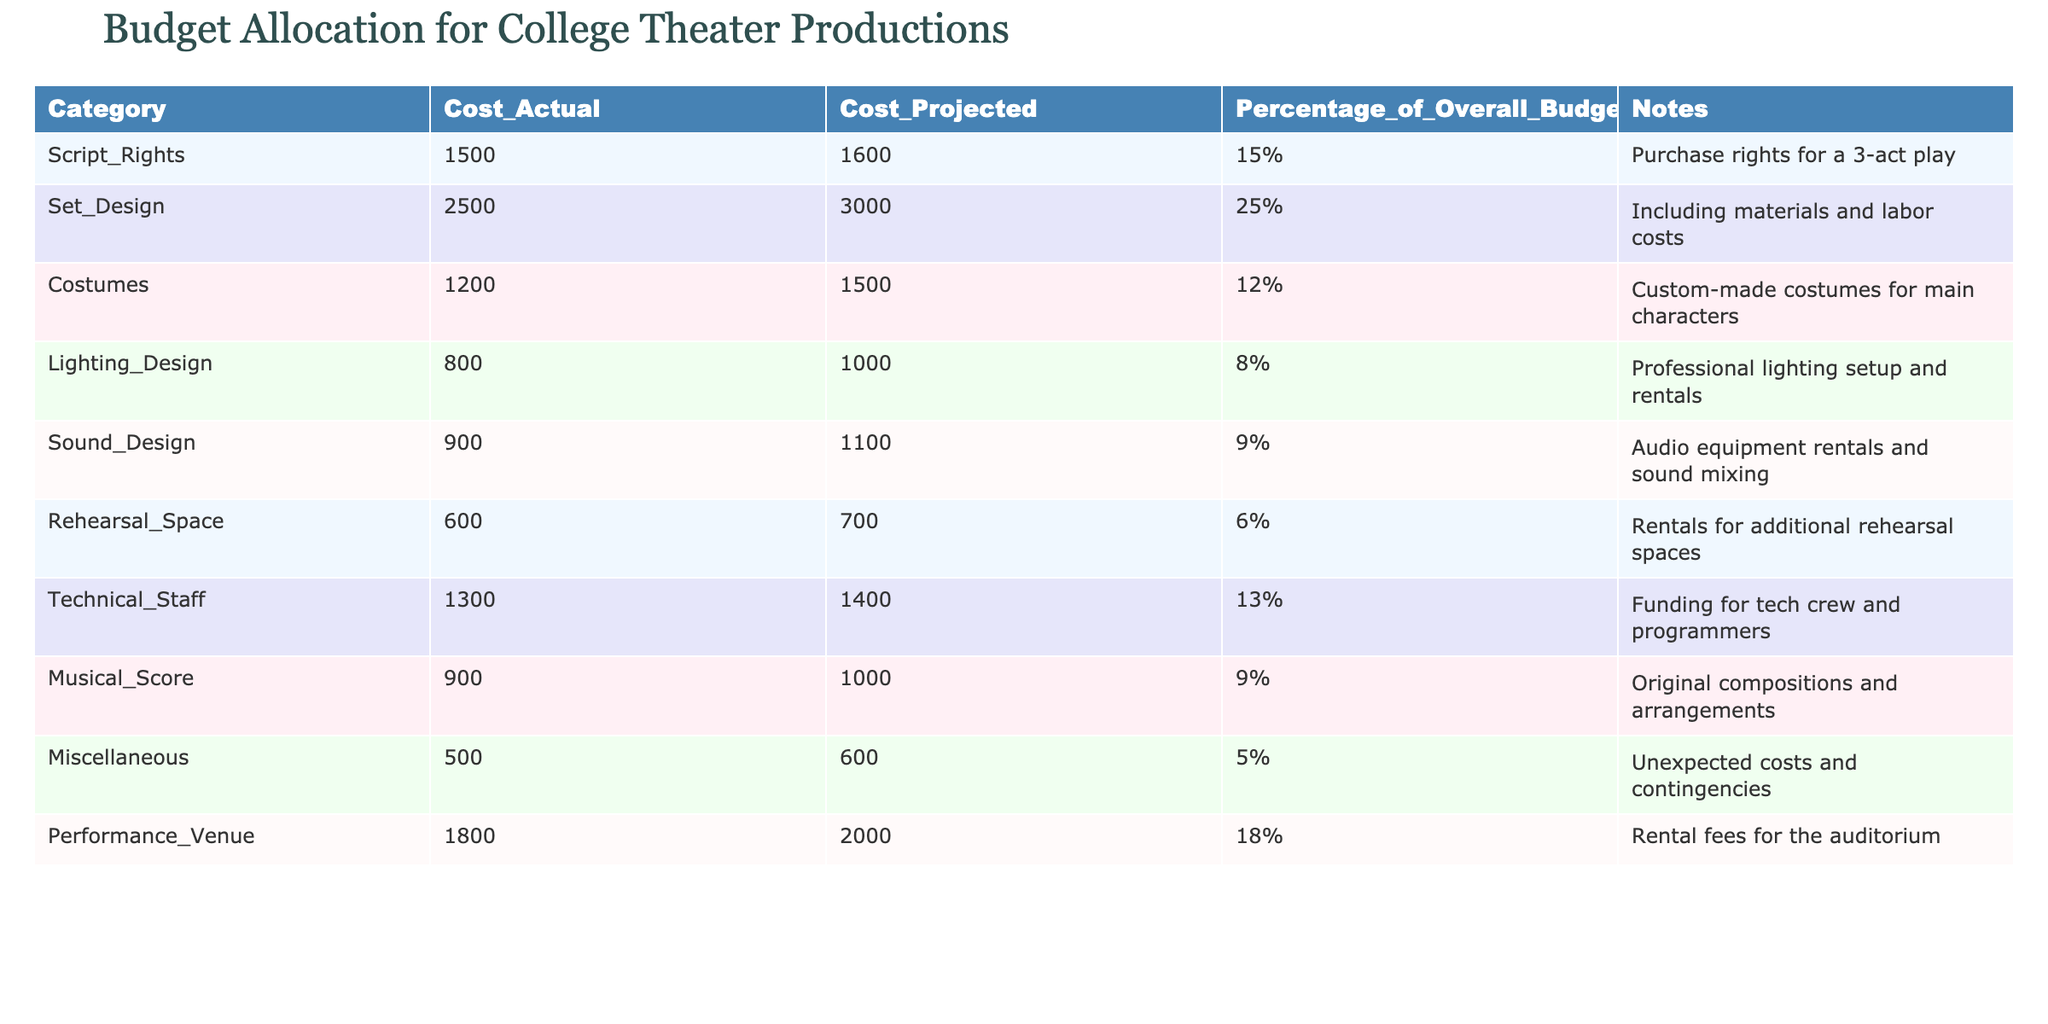What is the actual cost of Set Design? The table indicates that the actual cost for Set Design is listed under the Cost_Actual column. Looking at the corresponding row for Set Design, the value is 2500.
Answer: 2500 What percentage of the overall budget is allocated to Costumes? The Percentage_of_Overall_Budget column shows the allocation for Costumes. In the Costumes row, the percentage is listed as 12%.
Answer: 12% Which category has the highest actual cost? To find the highest actual cost, compare the Cost_Actual values in all rows. Set Design has the highest cost at 2500.
Answer: Set Design Is the actual cost of Sound Design less than the projected cost? By comparing the Cost_Actual and Cost_Projected for Sound Design, the actual cost is 900 and the projected cost is 1100. Since 900 is less than 1100, the statement is true.
Answer: Yes What is the total projected cost for all categories? To find the total projected cost, sum the Cost_Projected values in all rows: 1600 + 3000 + 1500 + 1000 + 1100 + 700 + 1400 + 1000 + 600 + 2000 = 13900.
Answer: 13900 Which category has the least cost in terms of actual expenses? By reviewing the Cost_Actual values, the Miscellaneous category has the lowest actual cost, listed as 500.
Answer: Miscellaneous What is the difference between the projected and actual costs for Technical Staff? The projected cost for Technical Staff is 1400, and the actual cost is 1300. The difference is calculated as 1400 - 1300 = 100.
Answer: 100 If the total budget is 10000, what percentage of it is allocated to Lighting Design? First, find the actual cost of Lighting Design, which is 800, then calculate the percentage by (800/10000) * 100 = 8%.
Answer: 8% How much more is spent on Performance Venue compared to Rehearsal Space in actual costs? The actual cost for Performance Venue is 1800 and for Rehearsal Space, it is 600. The difference is 1800 - 600 = 1200.
Answer: 1200 Which categories have a projected cost of over 1000? By looking at the Cost_Projected values, the categories with projected costs over 1000 are Set Design, Costumes, Sound Design, Lighting Design, Technical Staff, and Performance Venue.
Answer: Set Design, Costumes, Sound Design, Lighting Design, Technical Staff, Performance Venue 